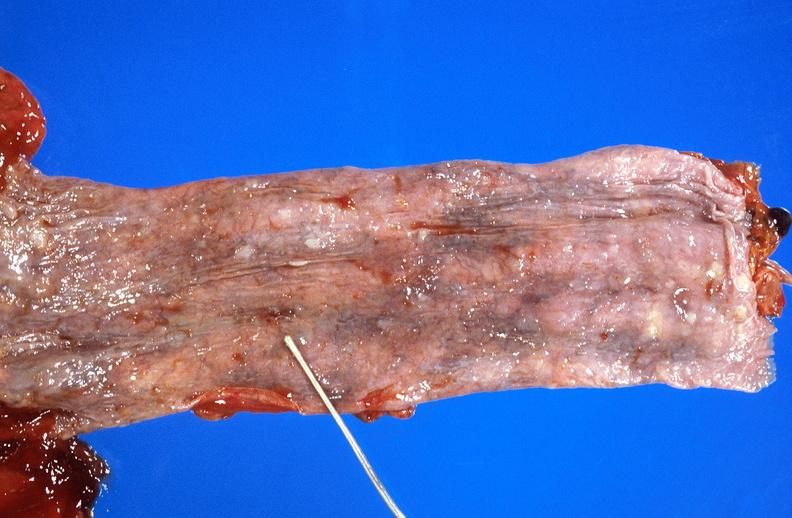what is present?
Answer the question using a single word or phrase. Gastrointestinal 